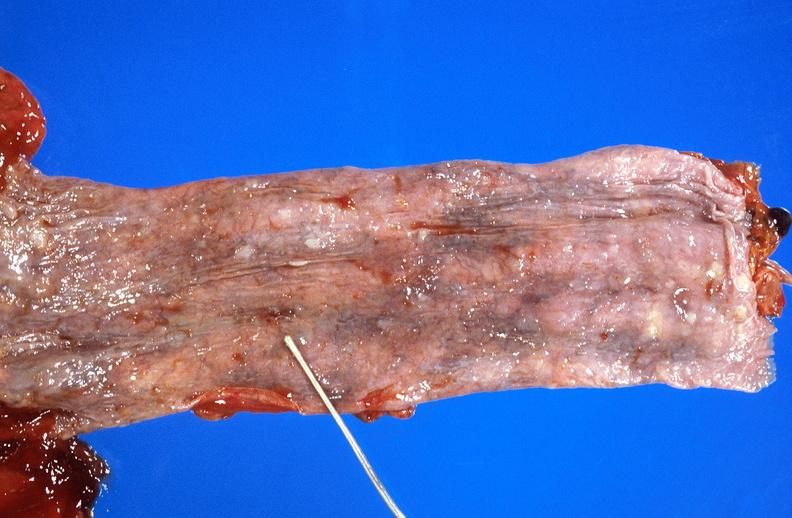what is present?
Answer the question using a single word or phrase. Gastrointestinal 